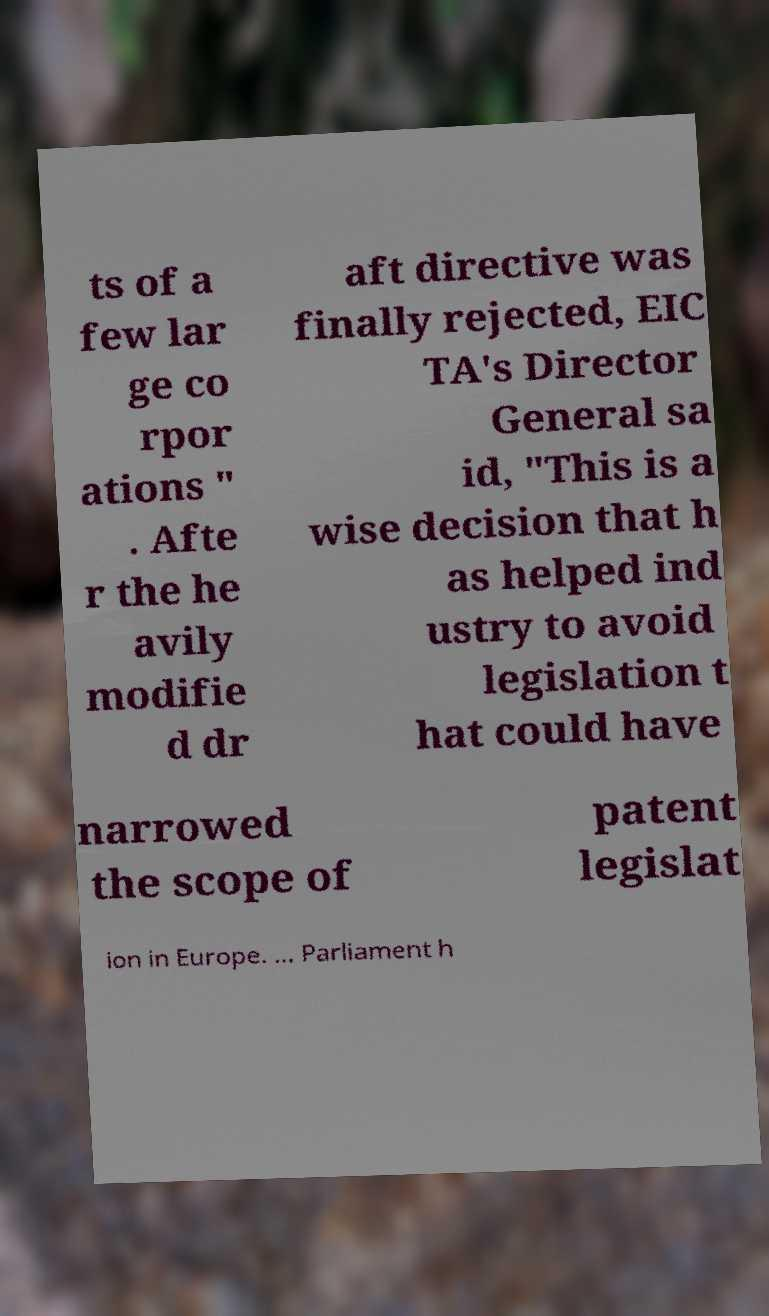Can you read and provide the text displayed in the image?This photo seems to have some interesting text. Can you extract and type it out for me? ts of a few lar ge co rpor ations " . Afte r the he avily modifie d dr aft directive was finally rejected, EIC TA's Director General sa id, "This is a wise decision that h as helped ind ustry to avoid legislation t hat could have narrowed the scope of patent legislat ion in Europe. ... Parliament h 